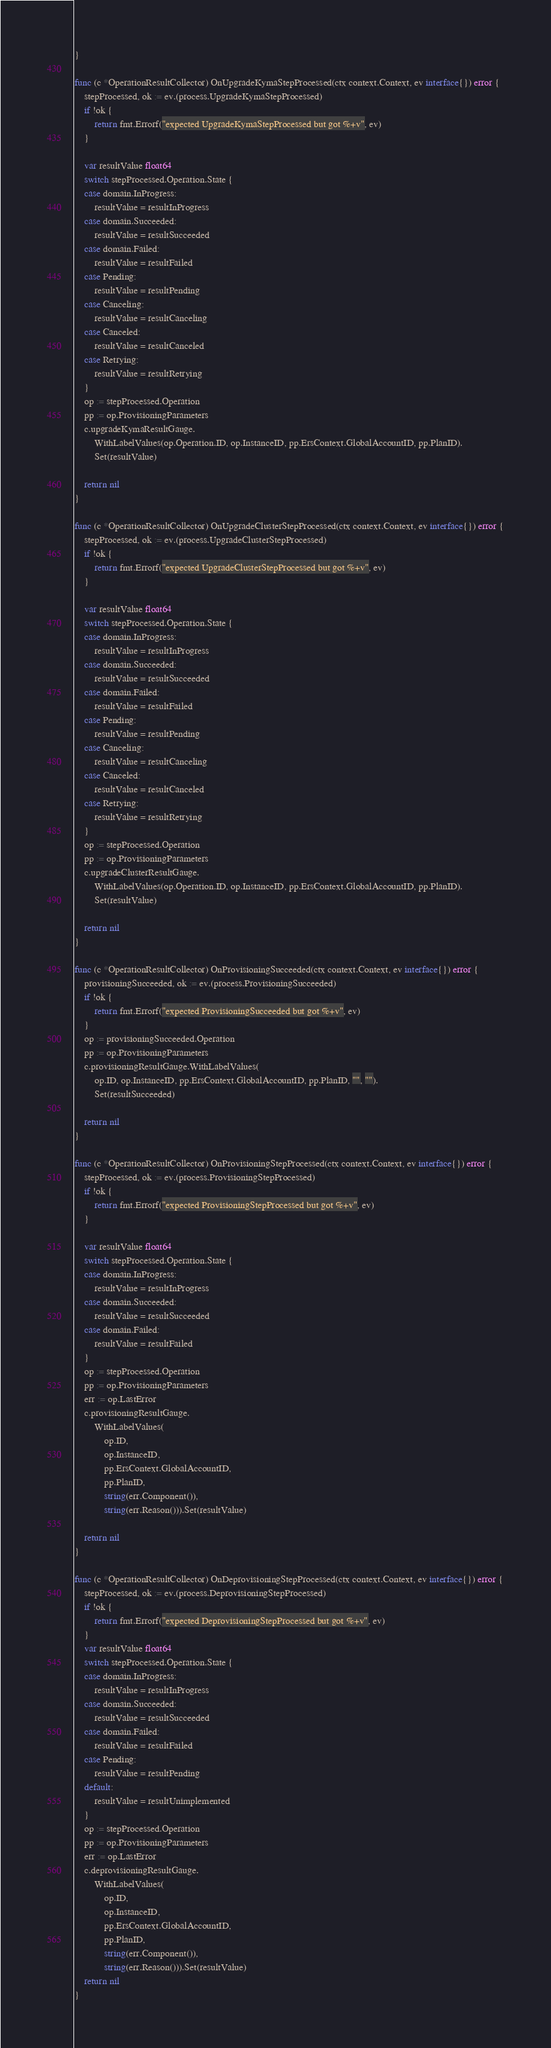Convert code to text. <code><loc_0><loc_0><loc_500><loc_500><_Go_>}

func (c *OperationResultCollector) OnUpgradeKymaStepProcessed(ctx context.Context, ev interface{}) error {
	stepProcessed, ok := ev.(process.UpgradeKymaStepProcessed)
	if !ok {
		return fmt.Errorf("expected UpgradeKymaStepProcessed but got %+v", ev)
	}

	var resultValue float64
	switch stepProcessed.Operation.State {
	case domain.InProgress:
		resultValue = resultInProgress
	case domain.Succeeded:
		resultValue = resultSucceeded
	case domain.Failed:
		resultValue = resultFailed
	case Pending:
		resultValue = resultPending
	case Canceling:
		resultValue = resultCanceling
	case Canceled:
		resultValue = resultCanceled
	case Retrying:
		resultValue = resultRetrying
	}
	op := stepProcessed.Operation
	pp := op.ProvisioningParameters
	c.upgradeKymaResultGauge.
		WithLabelValues(op.Operation.ID, op.InstanceID, pp.ErsContext.GlobalAccountID, pp.PlanID).
		Set(resultValue)

	return nil
}

func (c *OperationResultCollector) OnUpgradeClusterStepProcessed(ctx context.Context, ev interface{}) error {
	stepProcessed, ok := ev.(process.UpgradeClusterStepProcessed)
	if !ok {
		return fmt.Errorf("expected UpgradeClusterStepProcessed but got %+v", ev)
	}

	var resultValue float64
	switch stepProcessed.Operation.State {
	case domain.InProgress:
		resultValue = resultInProgress
	case domain.Succeeded:
		resultValue = resultSucceeded
	case domain.Failed:
		resultValue = resultFailed
	case Pending:
		resultValue = resultPending
	case Canceling:
		resultValue = resultCanceling
	case Canceled:
		resultValue = resultCanceled
	case Retrying:
		resultValue = resultRetrying
	}
	op := stepProcessed.Operation
	pp := op.ProvisioningParameters
	c.upgradeClusterResultGauge.
		WithLabelValues(op.Operation.ID, op.InstanceID, pp.ErsContext.GlobalAccountID, pp.PlanID).
		Set(resultValue)

	return nil
}

func (c *OperationResultCollector) OnProvisioningSucceeded(ctx context.Context, ev interface{}) error {
	provisioningSucceeded, ok := ev.(process.ProvisioningSucceeded)
	if !ok {
		return fmt.Errorf("expected ProvisioningSucceeded but got %+v", ev)
	}
	op := provisioningSucceeded.Operation
	pp := op.ProvisioningParameters
	c.provisioningResultGauge.WithLabelValues(
		op.ID, op.InstanceID, pp.ErsContext.GlobalAccountID, pp.PlanID, "", "").
		Set(resultSucceeded)

	return nil
}

func (c *OperationResultCollector) OnProvisioningStepProcessed(ctx context.Context, ev interface{}) error {
	stepProcessed, ok := ev.(process.ProvisioningStepProcessed)
	if !ok {
		return fmt.Errorf("expected ProvisioningStepProcessed but got %+v", ev)
	}

	var resultValue float64
	switch stepProcessed.Operation.State {
	case domain.InProgress:
		resultValue = resultInProgress
	case domain.Succeeded:
		resultValue = resultSucceeded
	case domain.Failed:
		resultValue = resultFailed
	}
	op := stepProcessed.Operation
	pp := op.ProvisioningParameters
	err := op.LastError
	c.provisioningResultGauge.
		WithLabelValues(
			op.ID,
			op.InstanceID,
			pp.ErsContext.GlobalAccountID,
			pp.PlanID,
			string(err.Component()),
			string(err.Reason())).Set(resultValue)

	return nil
}

func (c *OperationResultCollector) OnDeprovisioningStepProcessed(ctx context.Context, ev interface{}) error {
	stepProcessed, ok := ev.(process.DeprovisioningStepProcessed)
	if !ok {
		return fmt.Errorf("expected DeprovisioningStepProcessed but got %+v", ev)
	}
	var resultValue float64
	switch stepProcessed.Operation.State {
	case domain.InProgress:
		resultValue = resultInProgress
	case domain.Succeeded:
		resultValue = resultSucceeded
	case domain.Failed:
		resultValue = resultFailed
	case Pending:
		resultValue = resultPending
	default:
		resultValue = resultUnimplemented
	}
	op := stepProcessed.Operation
	pp := op.ProvisioningParameters
	err := op.LastError
	c.deprovisioningResultGauge.
		WithLabelValues(
			op.ID,
			op.InstanceID,
			pp.ErsContext.GlobalAccountID,
			pp.PlanID,
			string(err.Component()),
			string(err.Reason())).Set(resultValue)
	return nil
}
</code> 